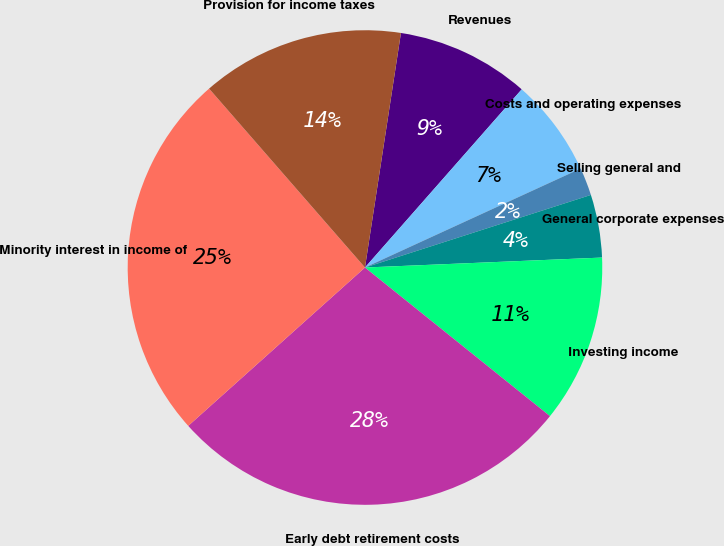Convert chart. <chart><loc_0><loc_0><loc_500><loc_500><pie_chart><fcel>Revenues<fcel>Costs and operating expenses<fcel>Selling general and<fcel>General corporate expenses<fcel>Investing income<fcel>Early debt retirement costs<fcel>Minority interest in income of<fcel>Provision for income taxes<nl><fcel>9.06%<fcel>6.67%<fcel>1.9%<fcel>4.28%<fcel>11.44%<fcel>27.6%<fcel>25.22%<fcel>13.83%<nl></chart> 